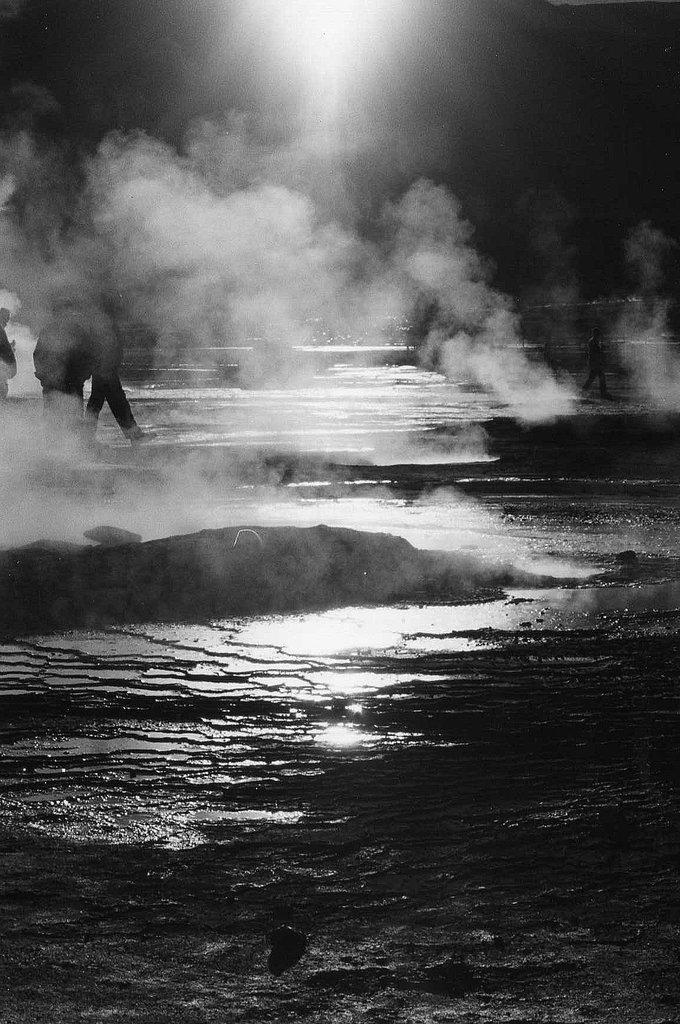What is the color scheme of the image? The image is black and white. What type of terrain can be seen in the image? There is land visible in the image. What is present in the air in the image? There is smoke in the air in the image. How many people are on the left side of the image? There are three persons on the left side of the image. What type of sugar is being used by the person on the right side of the image? There is no person on the right side of the image, and no sugar is visible in the image. How much muscle can be seen on the person in the center of the image? There are no visible persons in the image, so it is impossible to determine the amount of muscle present. 